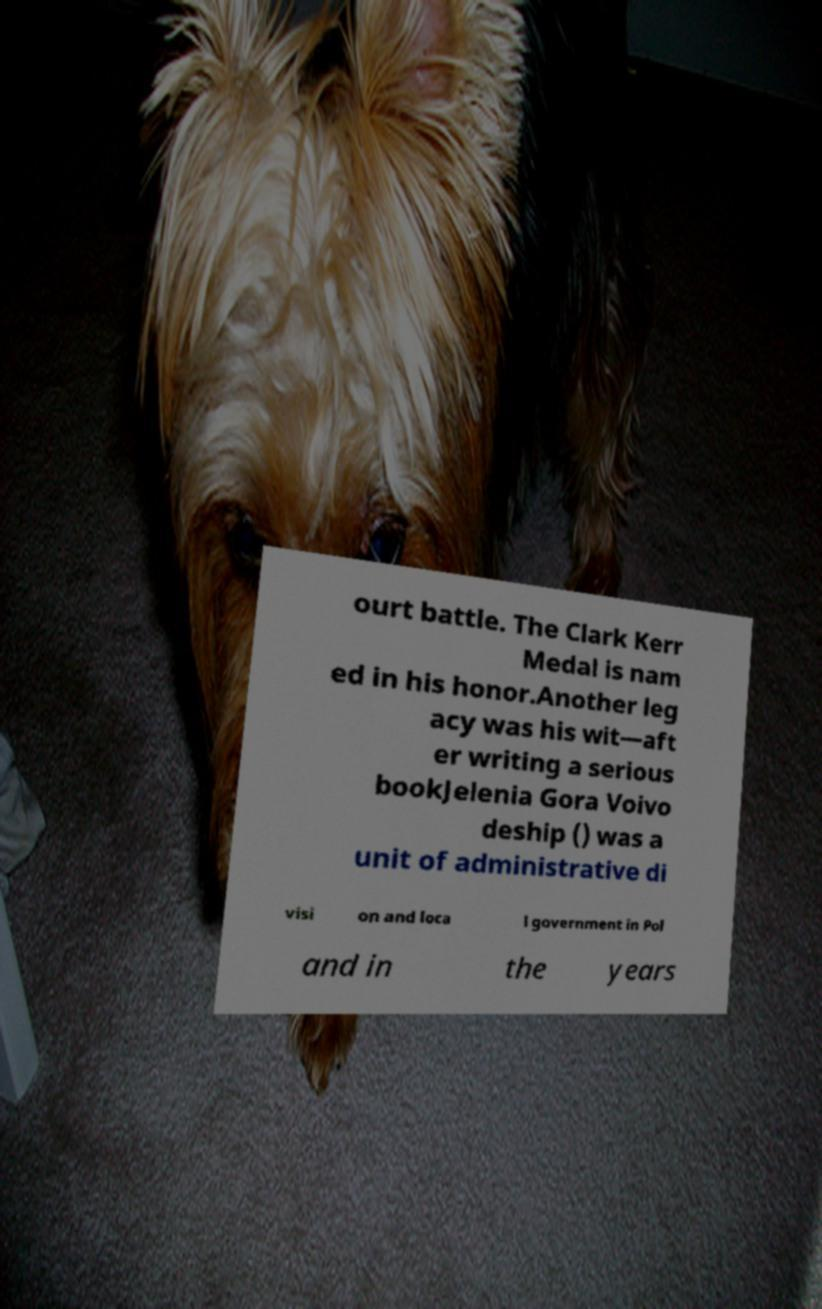Please read and relay the text visible in this image. What does it say? ourt battle. The Clark Kerr Medal is nam ed in his honor.Another leg acy was his wit—aft er writing a serious bookJelenia Gora Voivo deship () was a unit of administrative di visi on and loca l government in Pol and in the years 